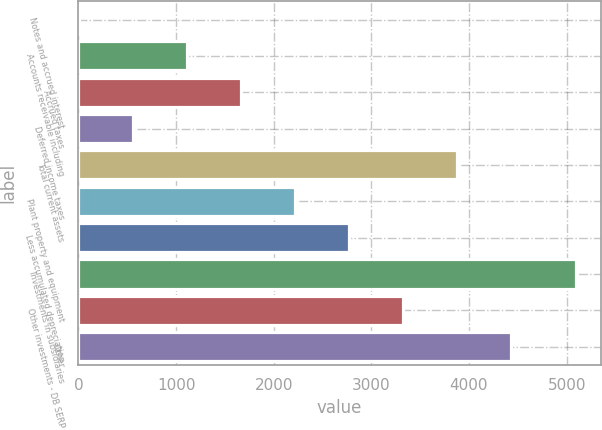<chart> <loc_0><loc_0><loc_500><loc_500><bar_chart><fcel>Notes and accrued interest<fcel>Accounts receivable including<fcel>Accrued taxes<fcel>Deferred income taxes<fcel>Total current assets<fcel>Plant property and equipment<fcel>Less accumulated depreciation<fcel>Investments in subsidiaries<fcel>Other investments - DB SERP<fcel>Other<nl><fcel>1<fcel>1108.8<fcel>1662.7<fcel>554.9<fcel>3878.3<fcel>2216.6<fcel>2770.5<fcel>5096<fcel>3324.4<fcel>4432.2<nl></chart> 